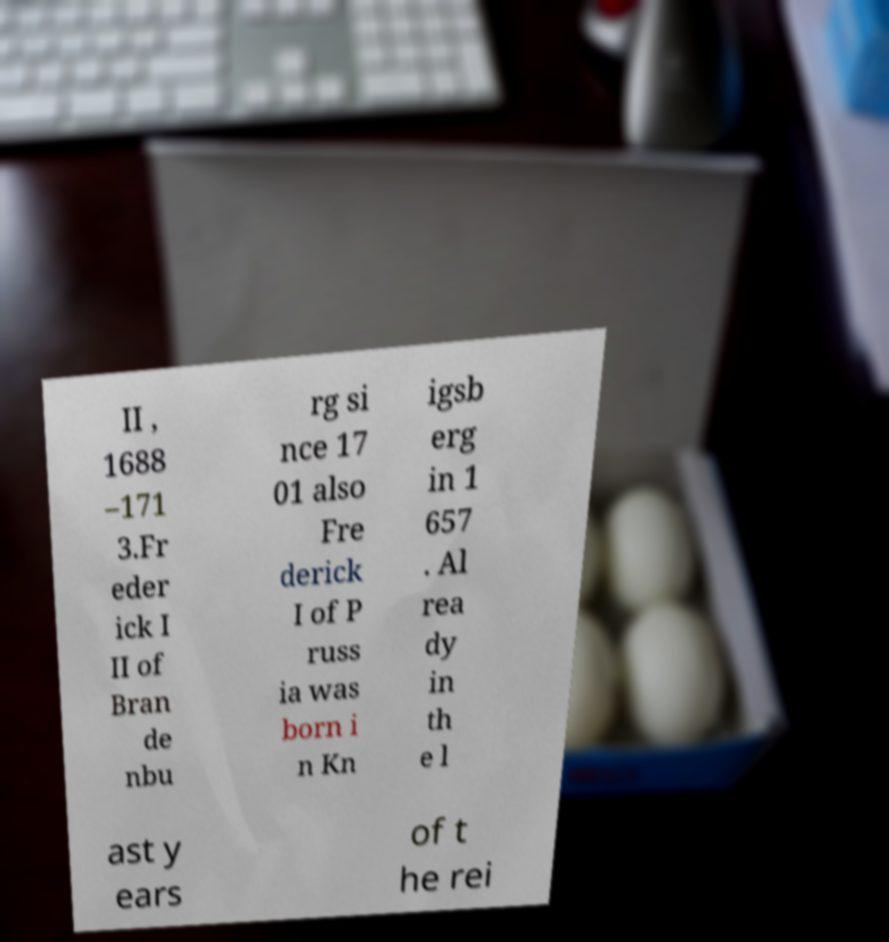Could you assist in decoding the text presented in this image and type it out clearly? II , 1688 –171 3.Fr eder ick I II of Bran de nbu rg si nce 17 01 also Fre derick I of P russ ia was born i n Kn igsb erg in 1 657 . Al rea dy in th e l ast y ears of t he rei 